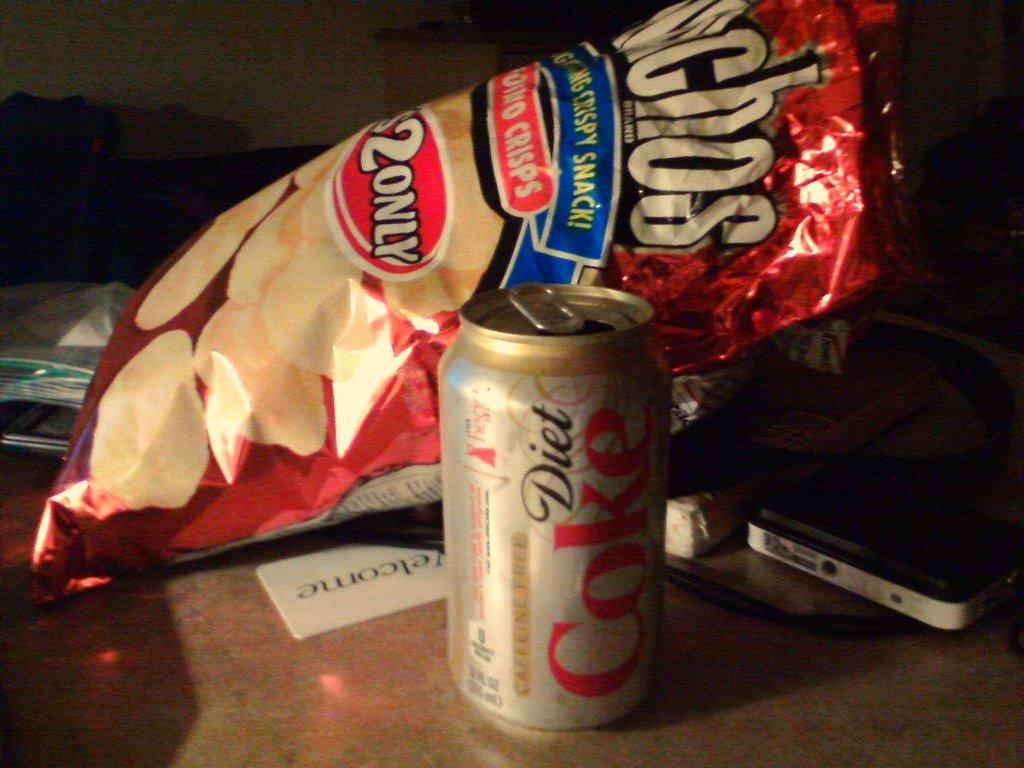<image>
Summarize the visual content of the image. A diet coke can sits beside a bag of chips. 